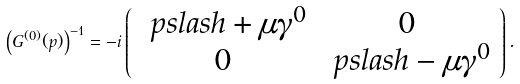Convert formula to latex. <formula><loc_0><loc_0><loc_500><loc_500>\left ( G ^ { ( 0 ) } ( p ) \right ) ^ { - 1 } = - i \left ( \begin{array} { c c } \ p s l a s h + \mu \gamma ^ { 0 } & 0 \\ 0 & \ p s l a s h - \mu \gamma ^ { 0 } \end{array} \right ) .</formula> 